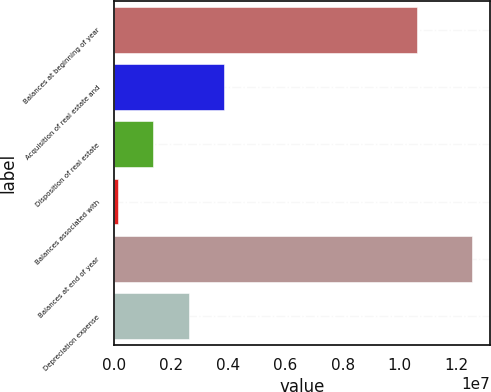<chart> <loc_0><loc_0><loc_500><loc_500><bar_chart><fcel>Balances at beginning of year<fcel>Acquisition of real estate and<fcel>Disposition of real estate<fcel>Balances associated with<fcel>Balances at end of year<fcel>Depreciation expense<nl><fcel>1.06167e+07<fcel>3.84342e+06<fcel>1.36319e+06<fcel>123073<fcel>1.25242e+07<fcel>2.6033e+06<nl></chart> 